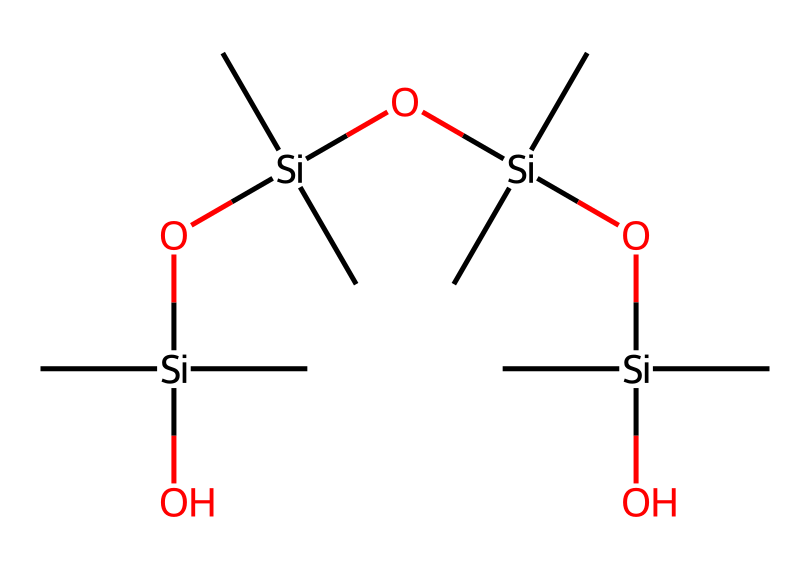What is the core element in this organosilicon compound? In the provided SMILES representation, the central atom is silicon, which is evident from the notation [Si] appearing at the beginning of the structure. This indicates that silicon is the primary element that connects to other groups.
Answer: silicon How many silicon atoms are present in this chemical structure? By examining the SMILES representation, we can identify multiple occurrences of [Si]. There is one central silicon and three additional silicon atoms connected in the chain, totaling four silicon atoms.
Answer: four What type of functional group is indicated by the terminal -O- in this chemical? The -O- in the structure indicates the presence of silanol groups or silicon-oxygen bonds, typically found in organosilicon compounds. This reflects the hydroxyl (-OH) functionality associated with silicon.
Answer: silanol What is the total number of carbon atoms in this structure? Counting the carbon atoms represented in the structure, we see that each of the three -C- groups attached to the silicon atoms contributes one carbon, with a total of twelve carbons from four -C- units (three bonded to each silicon). Therefore, it's calculated to be twelve carbon atoms in total.
Answer: twelve What characteristic of this chemical allows for improved grip in golf club coatings? The presence of multiple silanol groups and their ability to form hydrogen bonds with water contribute to improved tackiness and grip. This feature is beneficial when applied as a coating for golf clubs, giving players better control over swings.
Answer: tackiness How does the branching in this organosilicon structure affect its properties? The branched structure, with multiple silicon linked in a chain, enhances the flexibility and elasticity of the material. This contributes to improved durability and performance of the golf club grip compared to linear structures.
Answer: flexibility and elasticity What does the repeating unit of Si(C)2 signify in terms of bonding? The repeating unit Si(C)2 indicates that each silicon atom is bonded to two methyl groups. This gives insight into the three-dimensional arrangement of atoms and suggests how the molecule might interact with other surfaces, which is crucial for grip properties.
Answer: bonding arrangement 